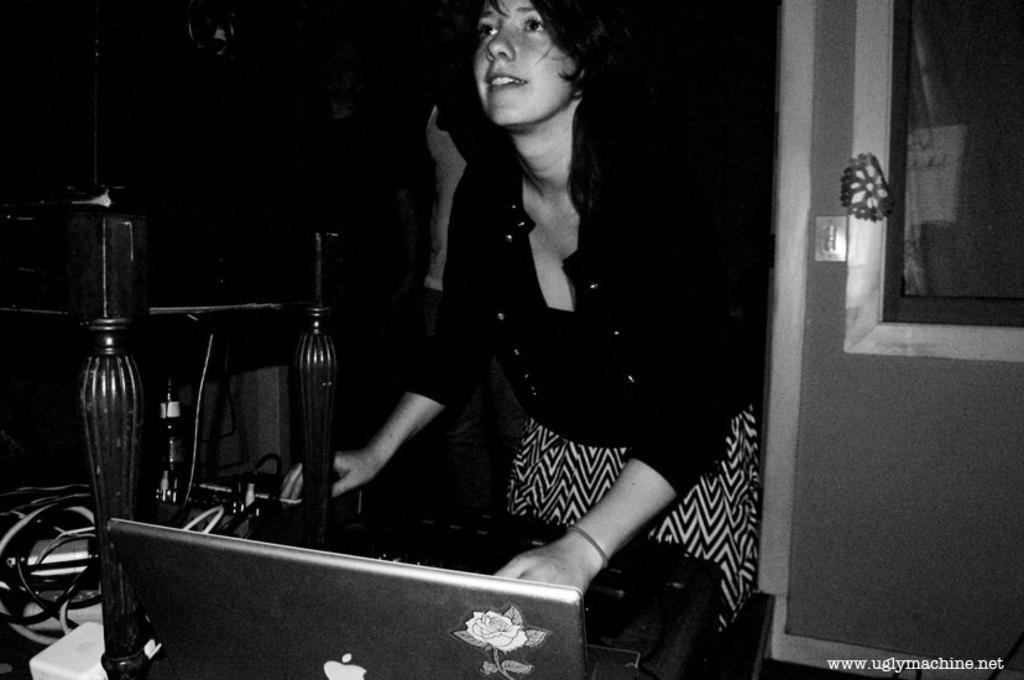How would you summarize this image in a sentence or two? This is black and white image in this image there is a lady standing, in front of her there is a table on that table there is a laptop, in the bottom right there is text. 